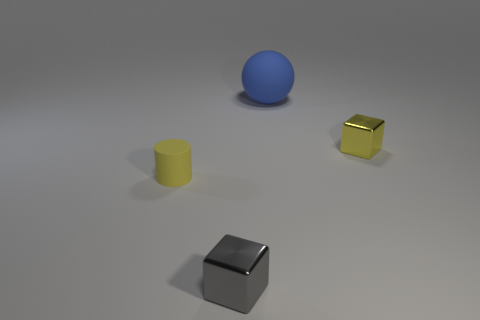The big object is what shape? The large object appears to be a perfect sphere with a smooth surface and a uniform blue color, typical of a ball. 